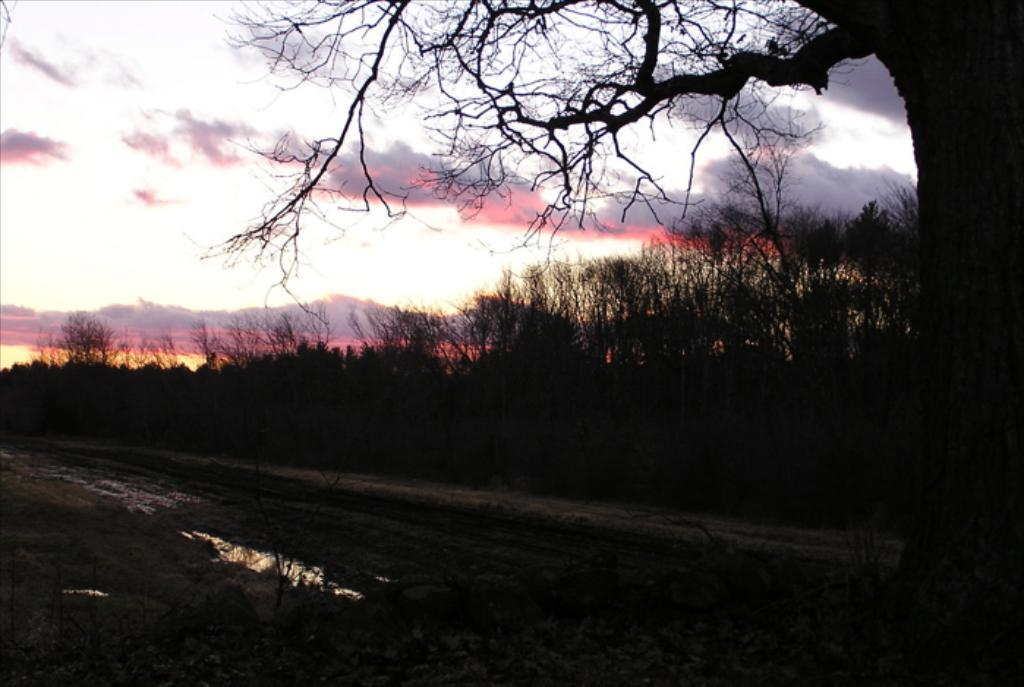What type of vegetation can be seen in the image? There are plants and trees visible in the image. What natural element is present in the image? Water is visible in the image. What can be seen in the background of the image? Hills and the sky are visible in the background. How would you describe the sky in the image? The sky appears cloudy. What is the weight of the icicle hanging from the tree in the image? There is no icicle present in the image, so it is not possible to determine its weight. 